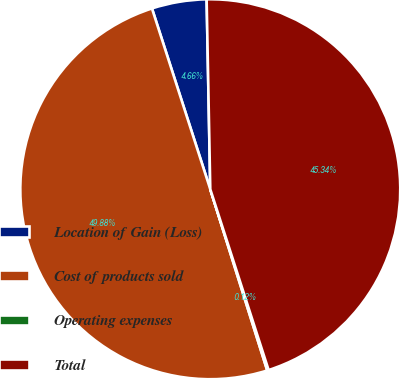<chart> <loc_0><loc_0><loc_500><loc_500><pie_chart><fcel>Location of Gain (Loss)<fcel>Cost of products sold<fcel>Operating expenses<fcel>Total<nl><fcel>4.66%<fcel>49.88%<fcel>0.12%<fcel>45.34%<nl></chart> 